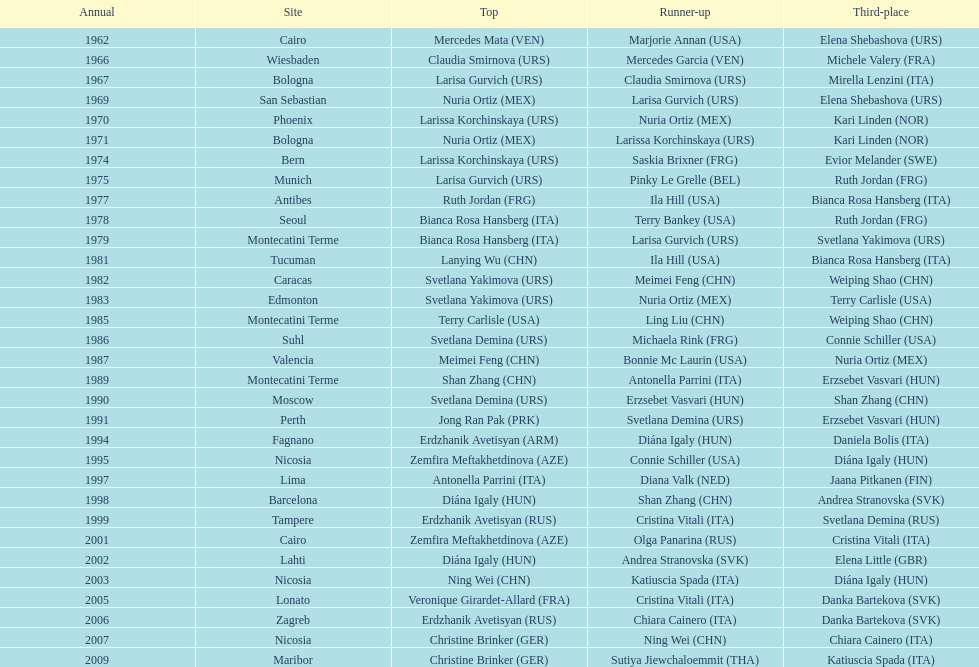What is the total amount of winnings for the united states in gold, silver and bronze? 9. 